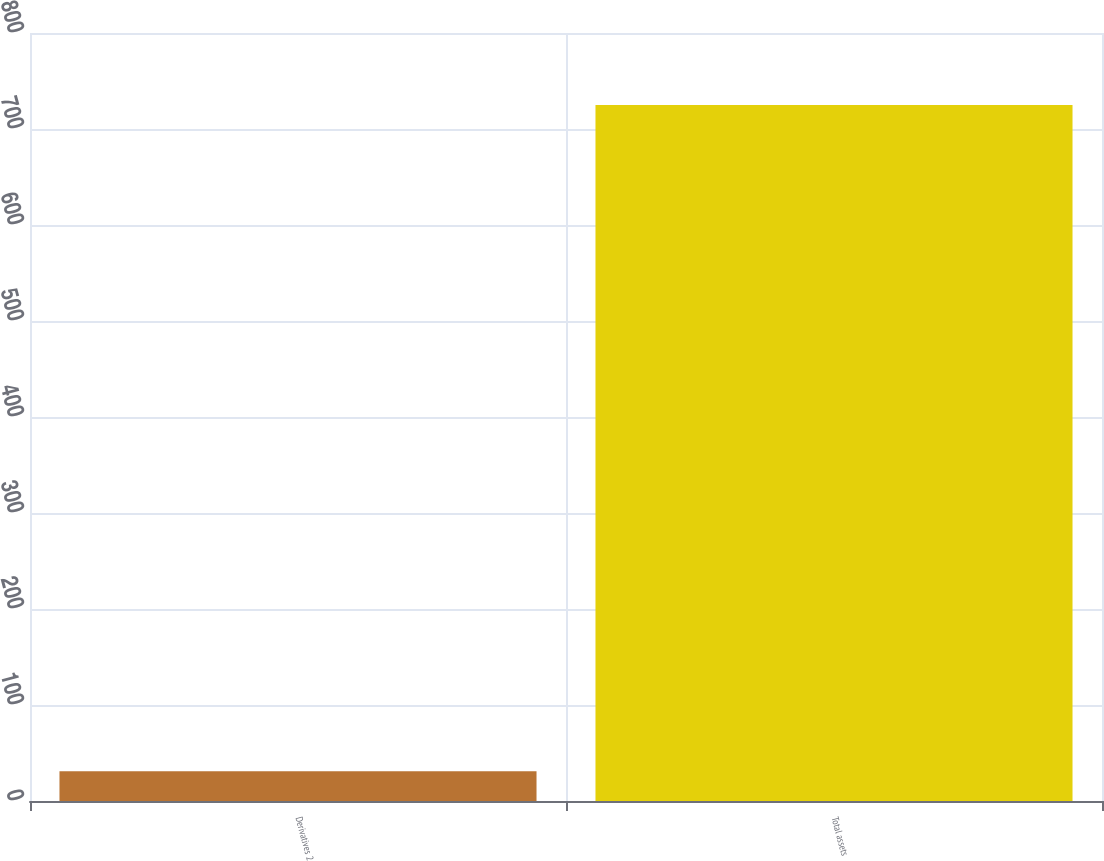Convert chart. <chart><loc_0><loc_0><loc_500><loc_500><bar_chart><fcel>Derivatives 2<fcel>Total assets<nl><fcel>31<fcel>725<nl></chart> 